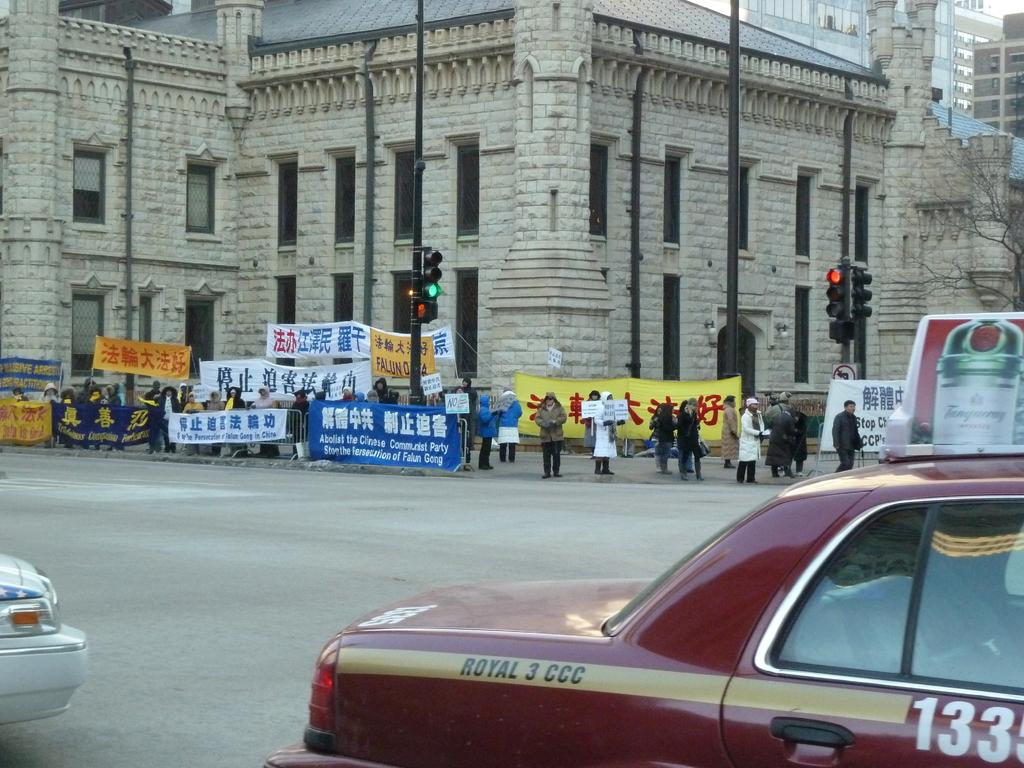Provide a one-sentence caption for the provided image. People holding signs that say abolish the Chinese Communist party written in english and chinese. 